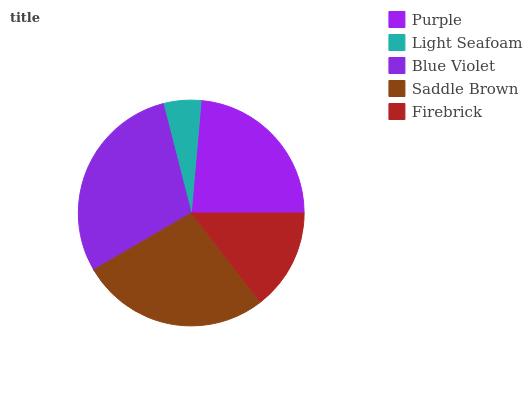Is Light Seafoam the minimum?
Answer yes or no. Yes. Is Blue Violet the maximum?
Answer yes or no. Yes. Is Blue Violet the minimum?
Answer yes or no. No. Is Light Seafoam the maximum?
Answer yes or no. No. Is Blue Violet greater than Light Seafoam?
Answer yes or no. Yes. Is Light Seafoam less than Blue Violet?
Answer yes or no. Yes. Is Light Seafoam greater than Blue Violet?
Answer yes or no. No. Is Blue Violet less than Light Seafoam?
Answer yes or no. No. Is Purple the high median?
Answer yes or no. Yes. Is Purple the low median?
Answer yes or no. Yes. Is Light Seafoam the high median?
Answer yes or no. No. Is Firebrick the low median?
Answer yes or no. No. 